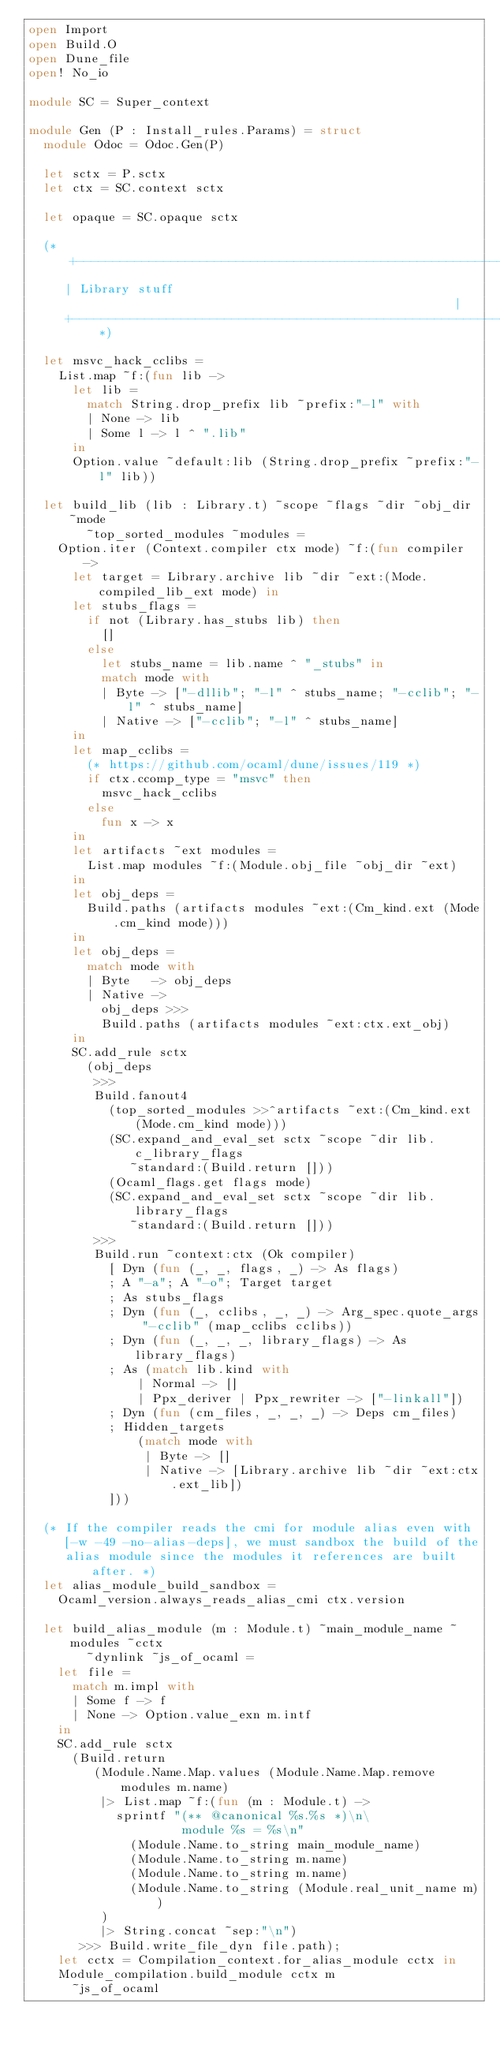<code> <loc_0><loc_0><loc_500><loc_500><_OCaml_>open Import
open Build.O
open Dune_file
open! No_io

module SC = Super_context

module Gen (P : Install_rules.Params) = struct
  module Odoc = Odoc.Gen(P)

  let sctx = P.sctx
  let ctx = SC.context sctx

  let opaque = SC.opaque sctx

  (* +-----------------------------------------------------------------+
     | Library stuff                                                   |
     +-----------------------------------------------------------------+ *)

  let msvc_hack_cclibs =
    List.map ~f:(fun lib ->
      let lib =
        match String.drop_prefix lib ~prefix:"-l" with
        | None -> lib
        | Some l -> l ^ ".lib"
      in
      Option.value ~default:lib (String.drop_prefix ~prefix:"-l" lib))

  let build_lib (lib : Library.t) ~scope ~flags ~dir ~obj_dir ~mode
        ~top_sorted_modules ~modules =
    Option.iter (Context.compiler ctx mode) ~f:(fun compiler ->
      let target = Library.archive lib ~dir ~ext:(Mode.compiled_lib_ext mode) in
      let stubs_flags =
        if not (Library.has_stubs lib) then
          []
        else
          let stubs_name = lib.name ^ "_stubs" in
          match mode with
          | Byte -> ["-dllib"; "-l" ^ stubs_name; "-cclib"; "-l" ^ stubs_name]
          | Native -> ["-cclib"; "-l" ^ stubs_name]
      in
      let map_cclibs =
        (* https://github.com/ocaml/dune/issues/119 *)
        if ctx.ccomp_type = "msvc" then
          msvc_hack_cclibs
        else
          fun x -> x
      in
      let artifacts ~ext modules =
        List.map modules ~f:(Module.obj_file ~obj_dir ~ext)
      in
      let obj_deps =
        Build.paths (artifacts modules ~ext:(Cm_kind.ext (Mode.cm_kind mode)))
      in
      let obj_deps =
        match mode with
        | Byte   -> obj_deps
        | Native ->
          obj_deps >>>
          Build.paths (artifacts modules ~ext:ctx.ext_obj)
      in
      SC.add_rule sctx
        (obj_deps
         >>>
         Build.fanout4
           (top_sorted_modules >>^artifacts ~ext:(Cm_kind.ext (Mode.cm_kind mode)))
           (SC.expand_and_eval_set sctx ~scope ~dir lib.c_library_flags
              ~standard:(Build.return []))
           (Ocaml_flags.get flags mode)
           (SC.expand_and_eval_set sctx ~scope ~dir lib.library_flags
              ~standard:(Build.return []))
         >>>
         Build.run ~context:ctx (Ok compiler)
           [ Dyn (fun (_, _, flags, _) -> As flags)
           ; A "-a"; A "-o"; Target target
           ; As stubs_flags
           ; Dyn (fun (_, cclibs, _, _) -> Arg_spec.quote_args "-cclib" (map_cclibs cclibs))
           ; Dyn (fun (_, _, _, library_flags) -> As library_flags)
           ; As (match lib.kind with
               | Normal -> []
               | Ppx_deriver | Ppx_rewriter -> ["-linkall"])
           ; Dyn (fun (cm_files, _, _, _) -> Deps cm_files)
           ; Hidden_targets
               (match mode with
                | Byte -> []
                | Native -> [Library.archive lib ~dir ~ext:ctx.ext_lib])
           ]))

  (* If the compiler reads the cmi for module alias even with
     [-w -49 -no-alias-deps], we must sandbox the build of the
     alias module since the modules it references are built after. *)
  let alias_module_build_sandbox =
    Ocaml_version.always_reads_alias_cmi ctx.version

  let build_alias_module (m : Module.t) ~main_module_name ~modules ~cctx
        ~dynlink ~js_of_ocaml =
    let file =
      match m.impl with
      | Some f -> f
      | None -> Option.value_exn m.intf
    in
    SC.add_rule sctx
      (Build.return
         (Module.Name.Map.values (Module.Name.Map.remove modules m.name)
          |> List.map ~f:(fun (m : Module.t) ->
            sprintf "(** @canonical %s.%s *)\n\
                     module %s = %s\n"
              (Module.Name.to_string main_module_name)
              (Module.Name.to_string m.name)
              (Module.Name.to_string m.name)
              (Module.Name.to_string (Module.real_unit_name m))
          )
          |> String.concat ~sep:"\n")
       >>> Build.write_file_dyn file.path);
    let cctx = Compilation_context.for_alias_module cctx in
    Module_compilation.build_module cctx m
      ~js_of_ocaml</code> 